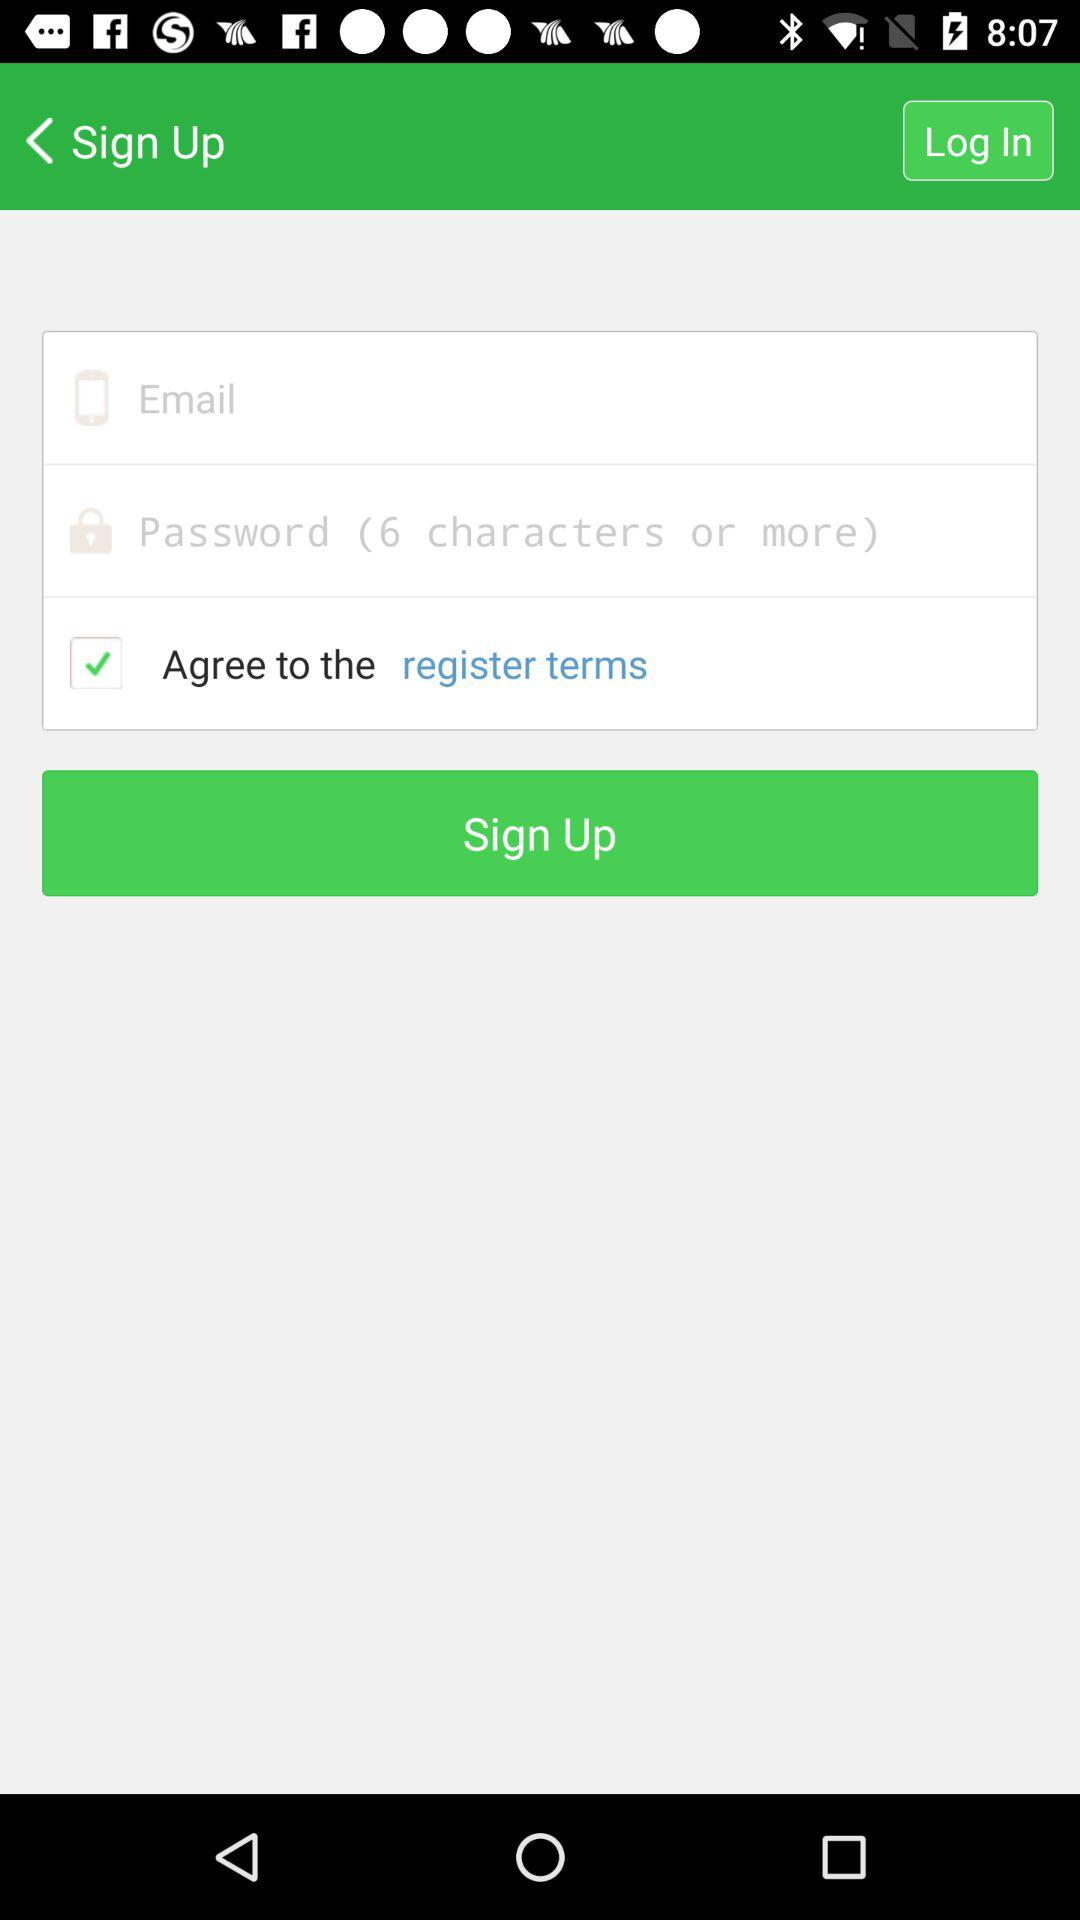What is the status of the option that includes agreement to the “register terms”? The status of the option that includes agreement to the "register terms" is "on". 